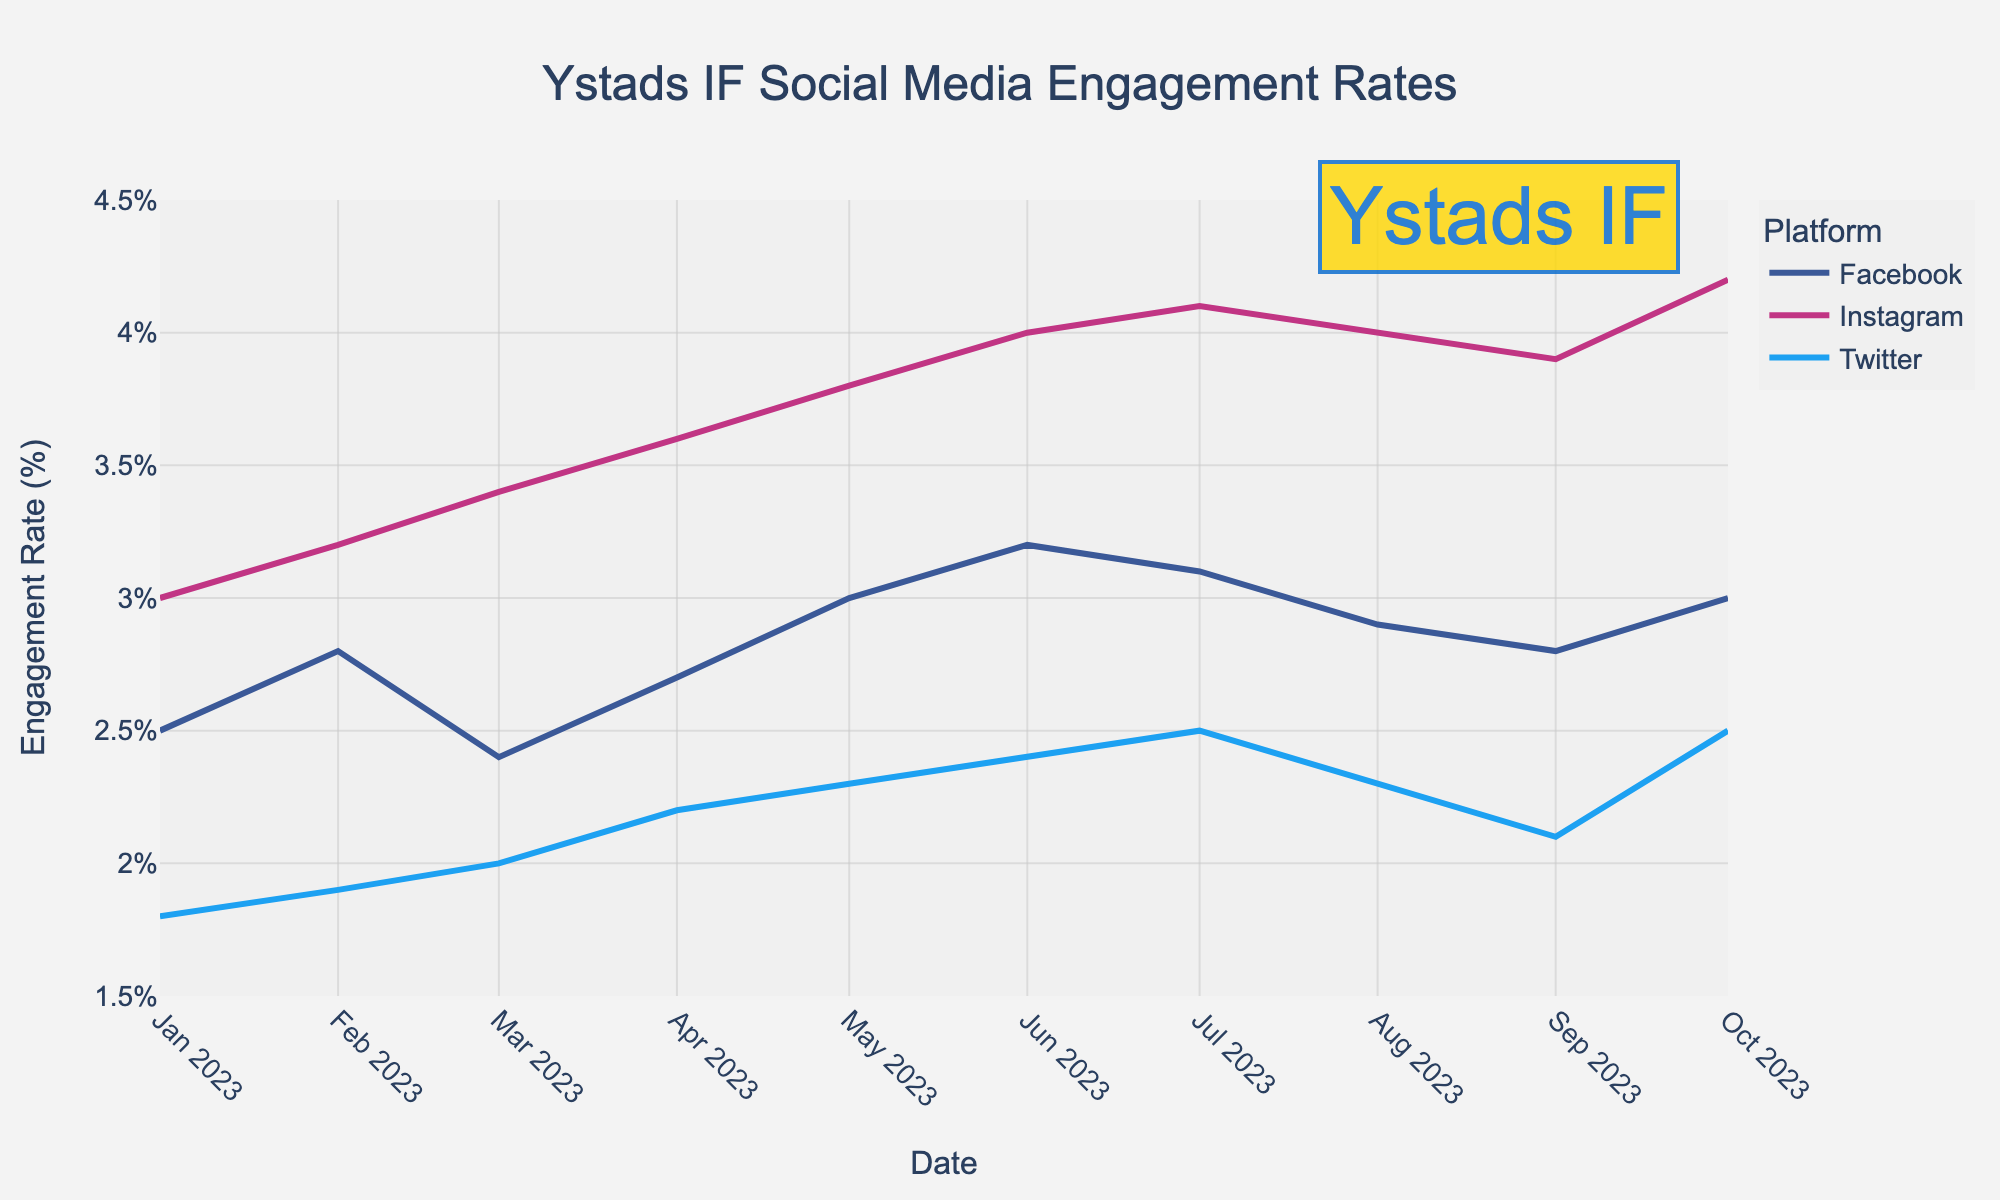What is the title of the plot? The title is usually placed at the top of the figure and describes the content of the plot. In this case, it is easily readable.
Answer: Ystads IF Social Media Engagement Rates How many platforms are represented in the plot? The different platforms are indicated by different colors in the plot legend.
Answer: Three (Facebook, Instagram, Twitter) Which platform had the highest engagement rate in October 2023? By looking at the plot values for October 2023, the line corresponding to Instagram reaches the highest point.
Answer: Instagram What is the engagement rate for Facebook in March 2023? Find the point on the Facebook line for March 2023 and read the engagement rate.
Answer: 2.4% What is the general trend for Instagram engagement rates from January to October 2023? Observe the Instagram line throughout the months. It shows an upward trend.
Answer: Increasing By how much did Twitter's engagement rate change from January to October 2023? Subtract the engagement rate of Twitter in January from that in October (2.5% - 1.8%).
Answer: 0.7% Which month experienced the highest engagement rate across all platforms? Identify the peak points of all lines and note the month. October 2023 has the highest point for Instagram.
Answer: October 2023 Which platform had the lowest average engagement rate over the given period? Calculate the average engagement rate for each platform (sum/number of months). Compare to find the lowest.
Answer: Twitter Was there any month where all three platforms had the same engagement rate? Look through each month to see if all platforms' lines converge to the same point.
Answer: No Which platform showed the most consistent engagement rates over the period? Look for the platform line that shows the least fluctuation.
Answer: Twitter 